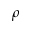<formula> <loc_0><loc_0><loc_500><loc_500>\rho</formula> 